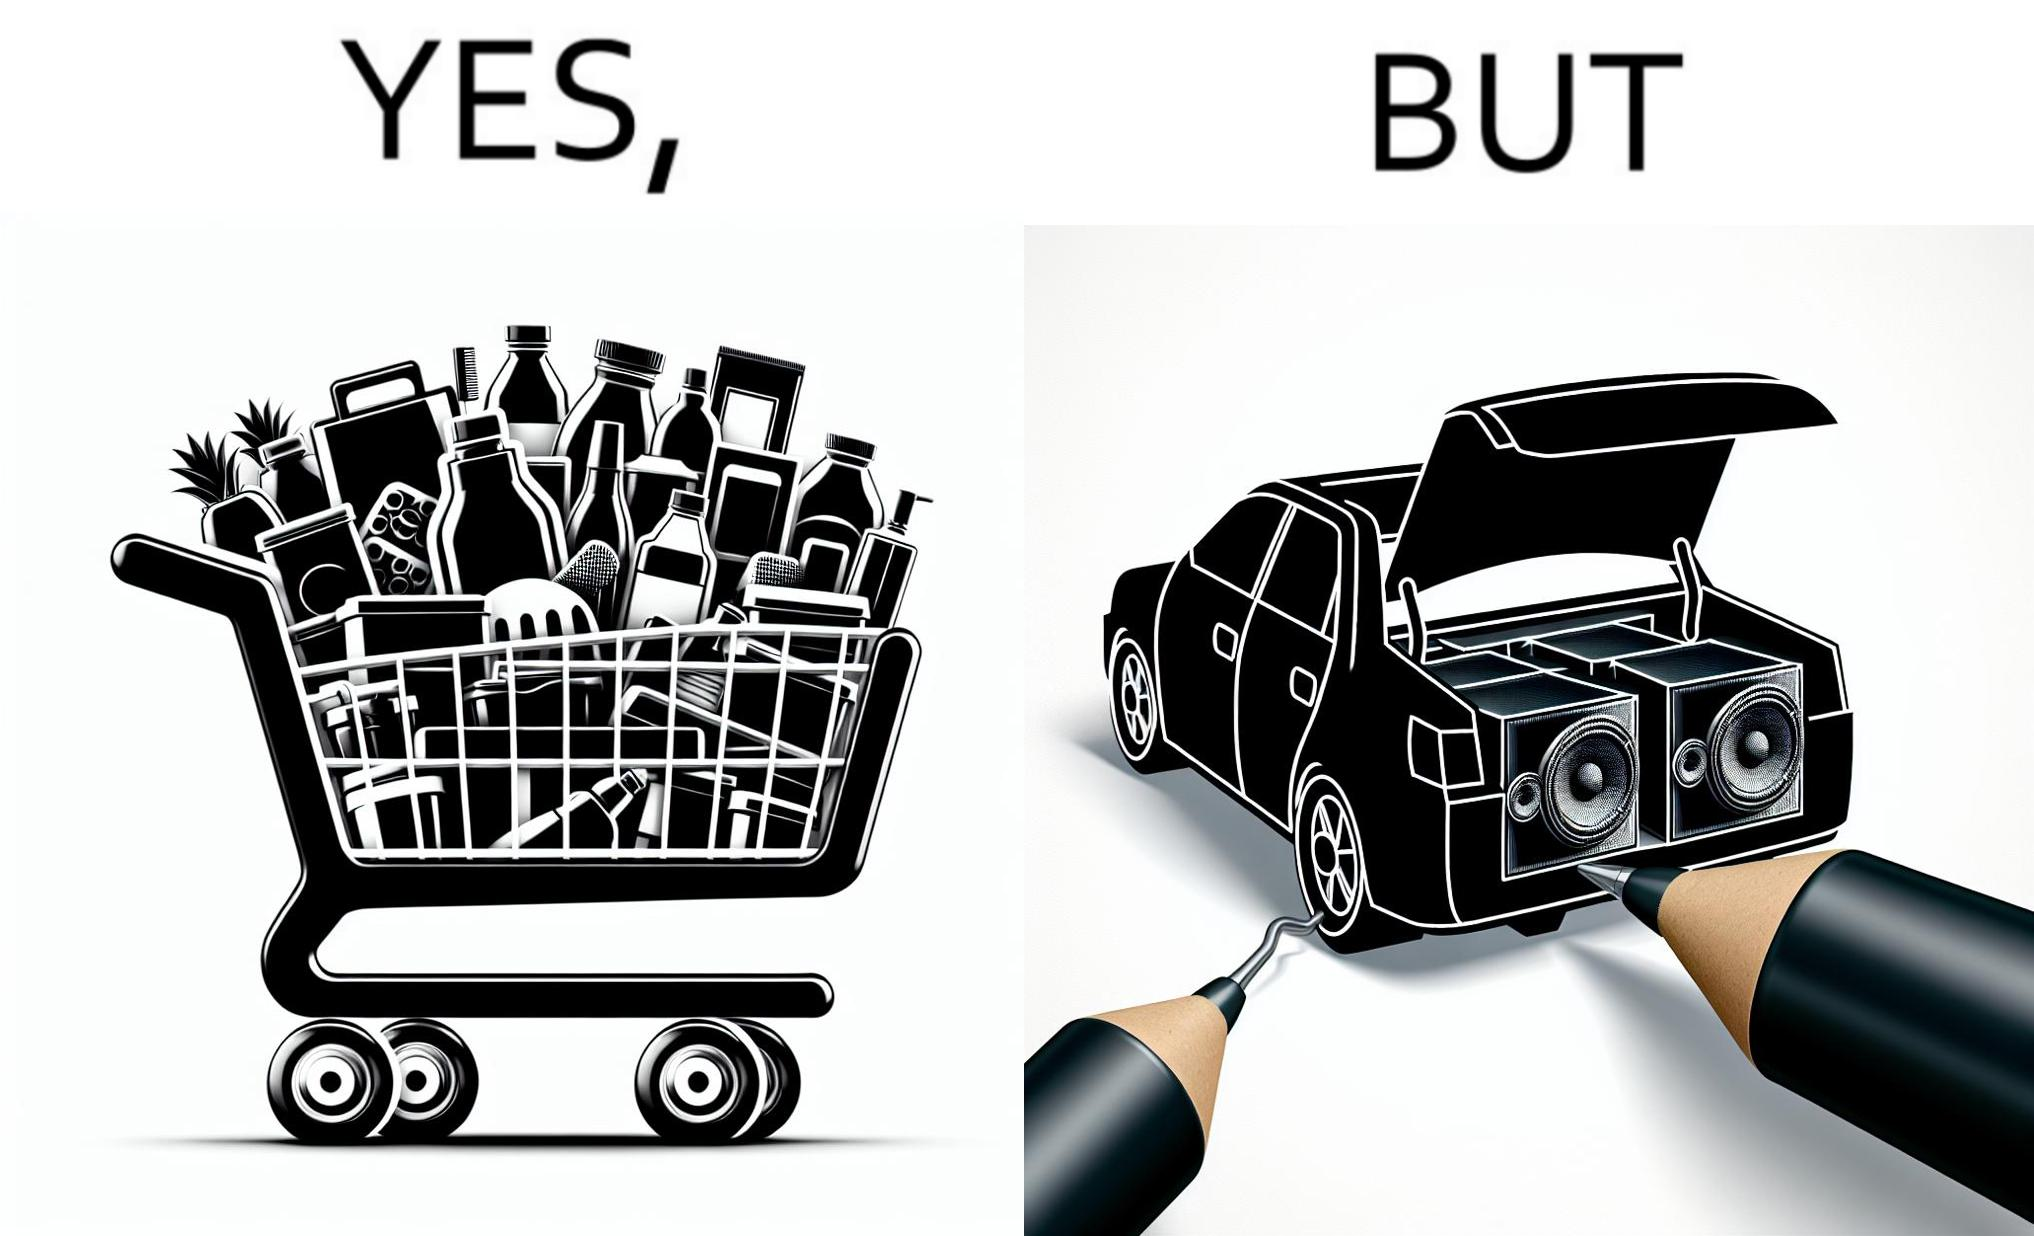What is shown in the left half versus the right half of this image? In the left part of the image: a shopping cart full of items In the right part of the image: a black car with its trunk lid open and some boxes, probably speakers, kept in the trunk 